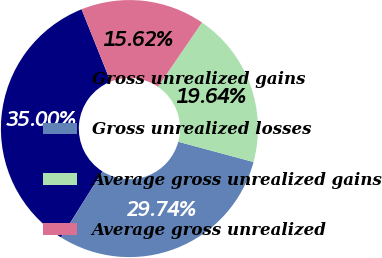<chart> <loc_0><loc_0><loc_500><loc_500><pie_chart><fcel>Gross unrealized gains<fcel>Gross unrealized losses<fcel>Average gross unrealized gains<fcel>Average gross unrealized<nl><fcel>35.0%<fcel>29.74%<fcel>19.64%<fcel>15.62%<nl></chart> 